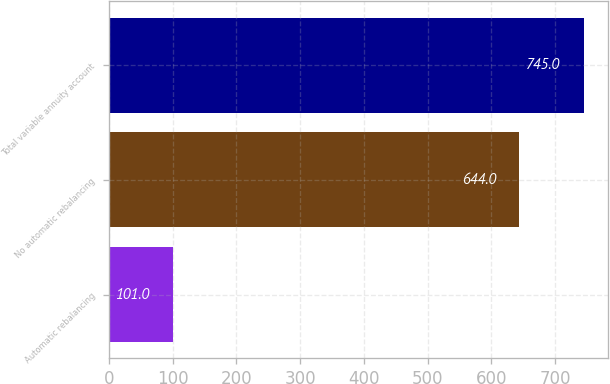Convert chart. <chart><loc_0><loc_0><loc_500><loc_500><bar_chart><fcel>Automatic rebalancing<fcel>No automatic rebalancing<fcel>Total variable annuity account<nl><fcel>101<fcel>644<fcel>745<nl></chart> 